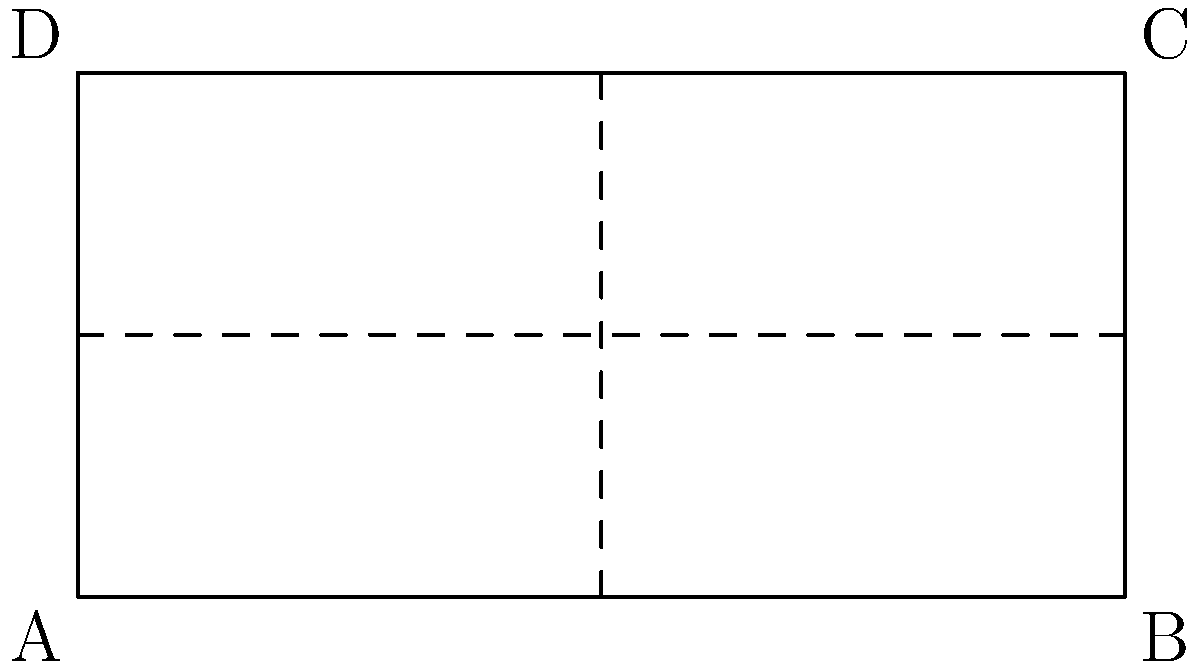The diagram shows a 2D representation of the Texas A&M-Corpus Christi Islanders basketball court and a 3D model of the arena. If the court is folded along the dashed lines to create the 3D arena, which corner of the 2D court (A, B, C, or D) will correspond to point C' in the 3D model? To solve this problem, we need to mentally fold the 2D court along the dashed lines to create the 3D arena. Let's follow these steps:

1. The vertical dashed line in the middle of the court represents the fold that will create the length of the arena.
2. The horizontal dashed line represents the fold that will create the height of the arena.

3. Point C' in the 3D model is at the top right corner when viewed from the front.
4. To reach this position, we need to:
   a) Fold the right half of the court up along the horizontal dashed line.
   b) Then fold the entire court in half along the vertical dashed line.

5. After these folds:
   - The bottom right corner (B) will be at the front bottom.
   - The top right corner (C) will be at the front top.
   - The left side of the court will be at the back of the arena.

6. Therefore, the corner C from the 2D court will correspond to point C' in the 3D model.
Answer: C 